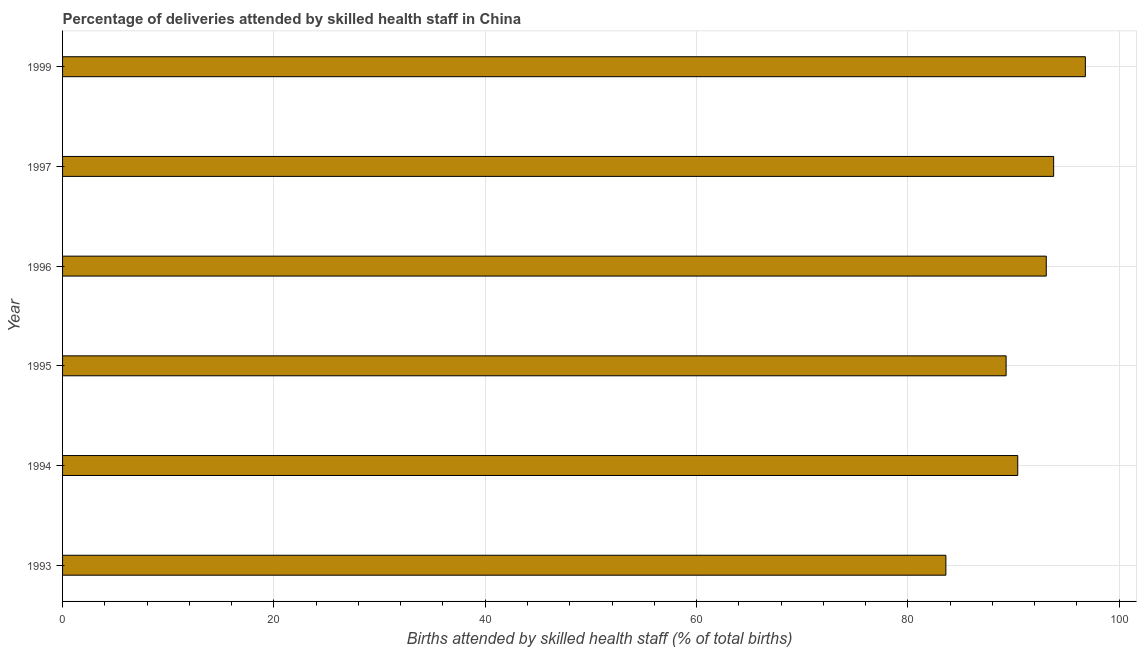What is the title of the graph?
Provide a succinct answer. Percentage of deliveries attended by skilled health staff in China. What is the label or title of the X-axis?
Ensure brevity in your answer.  Births attended by skilled health staff (% of total births). What is the number of births attended by skilled health staff in 1996?
Provide a succinct answer. 93.1. Across all years, what is the maximum number of births attended by skilled health staff?
Ensure brevity in your answer.  96.8. Across all years, what is the minimum number of births attended by skilled health staff?
Provide a short and direct response. 83.6. In which year was the number of births attended by skilled health staff minimum?
Offer a terse response. 1993. What is the sum of the number of births attended by skilled health staff?
Your response must be concise. 547. What is the average number of births attended by skilled health staff per year?
Your response must be concise. 91.17. What is the median number of births attended by skilled health staff?
Give a very brief answer. 91.75. Do a majority of the years between 1999 and 1995 (inclusive) have number of births attended by skilled health staff greater than 8 %?
Provide a short and direct response. Yes. What is the ratio of the number of births attended by skilled health staff in 1994 to that in 1996?
Give a very brief answer. 0.97. Is the sum of the number of births attended by skilled health staff in 1993 and 1995 greater than the maximum number of births attended by skilled health staff across all years?
Provide a short and direct response. Yes. Are all the bars in the graph horizontal?
Provide a succinct answer. Yes. What is the Births attended by skilled health staff (% of total births) in 1993?
Your answer should be very brief. 83.6. What is the Births attended by skilled health staff (% of total births) in 1994?
Make the answer very short. 90.4. What is the Births attended by skilled health staff (% of total births) of 1995?
Give a very brief answer. 89.3. What is the Births attended by skilled health staff (% of total births) of 1996?
Your response must be concise. 93.1. What is the Births attended by skilled health staff (% of total births) of 1997?
Your answer should be compact. 93.8. What is the Births attended by skilled health staff (% of total births) in 1999?
Your answer should be very brief. 96.8. What is the difference between the Births attended by skilled health staff (% of total births) in 1993 and 1994?
Make the answer very short. -6.8. What is the difference between the Births attended by skilled health staff (% of total births) in 1993 and 1999?
Make the answer very short. -13.2. What is the difference between the Births attended by skilled health staff (% of total births) in 1994 and 1995?
Make the answer very short. 1.1. What is the difference between the Births attended by skilled health staff (% of total births) in 1994 and 1997?
Provide a short and direct response. -3.4. What is the difference between the Births attended by skilled health staff (% of total births) in 1995 and 1997?
Give a very brief answer. -4.5. What is the difference between the Births attended by skilled health staff (% of total births) in 1995 and 1999?
Your response must be concise. -7.5. What is the difference between the Births attended by skilled health staff (% of total births) in 1996 and 1999?
Your response must be concise. -3.7. What is the ratio of the Births attended by skilled health staff (% of total births) in 1993 to that in 1994?
Your answer should be compact. 0.93. What is the ratio of the Births attended by skilled health staff (% of total births) in 1993 to that in 1995?
Give a very brief answer. 0.94. What is the ratio of the Births attended by skilled health staff (% of total births) in 1993 to that in 1996?
Provide a succinct answer. 0.9. What is the ratio of the Births attended by skilled health staff (% of total births) in 1993 to that in 1997?
Provide a short and direct response. 0.89. What is the ratio of the Births attended by skilled health staff (% of total births) in 1993 to that in 1999?
Ensure brevity in your answer.  0.86. What is the ratio of the Births attended by skilled health staff (% of total births) in 1994 to that in 1996?
Your answer should be very brief. 0.97. What is the ratio of the Births attended by skilled health staff (% of total births) in 1994 to that in 1997?
Offer a terse response. 0.96. What is the ratio of the Births attended by skilled health staff (% of total births) in 1994 to that in 1999?
Your response must be concise. 0.93. What is the ratio of the Births attended by skilled health staff (% of total births) in 1995 to that in 1999?
Provide a short and direct response. 0.92. What is the ratio of the Births attended by skilled health staff (% of total births) in 1996 to that in 1997?
Your answer should be compact. 0.99. What is the ratio of the Births attended by skilled health staff (% of total births) in 1996 to that in 1999?
Give a very brief answer. 0.96. What is the ratio of the Births attended by skilled health staff (% of total births) in 1997 to that in 1999?
Your answer should be very brief. 0.97. 